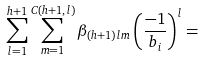<formula> <loc_0><loc_0><loc_500><loc_500>\sum _ { l = 1 } ^ { h + 1 } \sum _ { m = 1 } ^ { C ( h + 1 , l ) } \beta _ { ( h + 1 ) l m } \left ( \frac { - 1 } { b _ { i } } \right ) ^ { l } =</formula> 